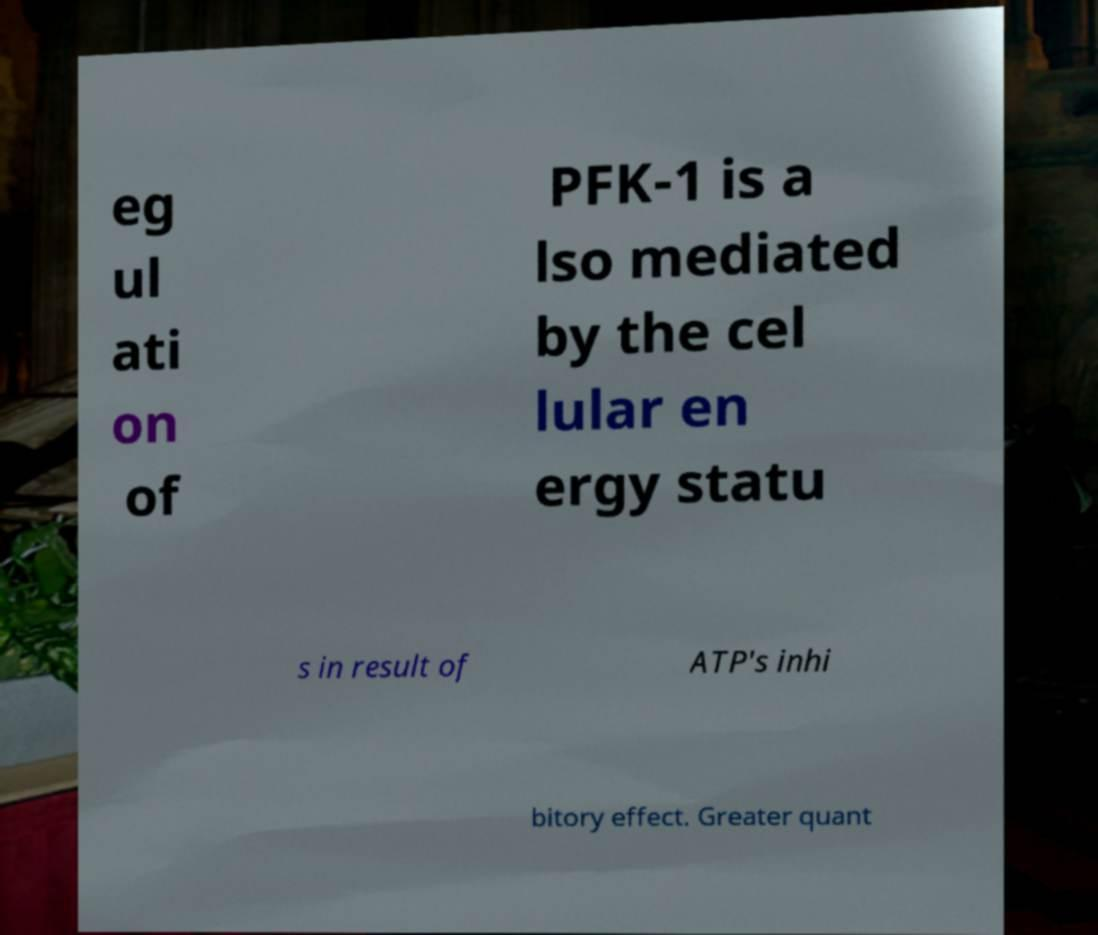There's text embedded in this image that I need extracted. Can you transcribe it verbatim? eg ul ati on of PFK-1 is a lso mediated by the cel lular en ergy statu s in result of ATP's inhi bitory effect. Greater quant 